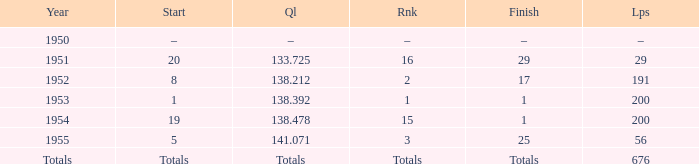What ranking that had a start of 19? 15.0. 